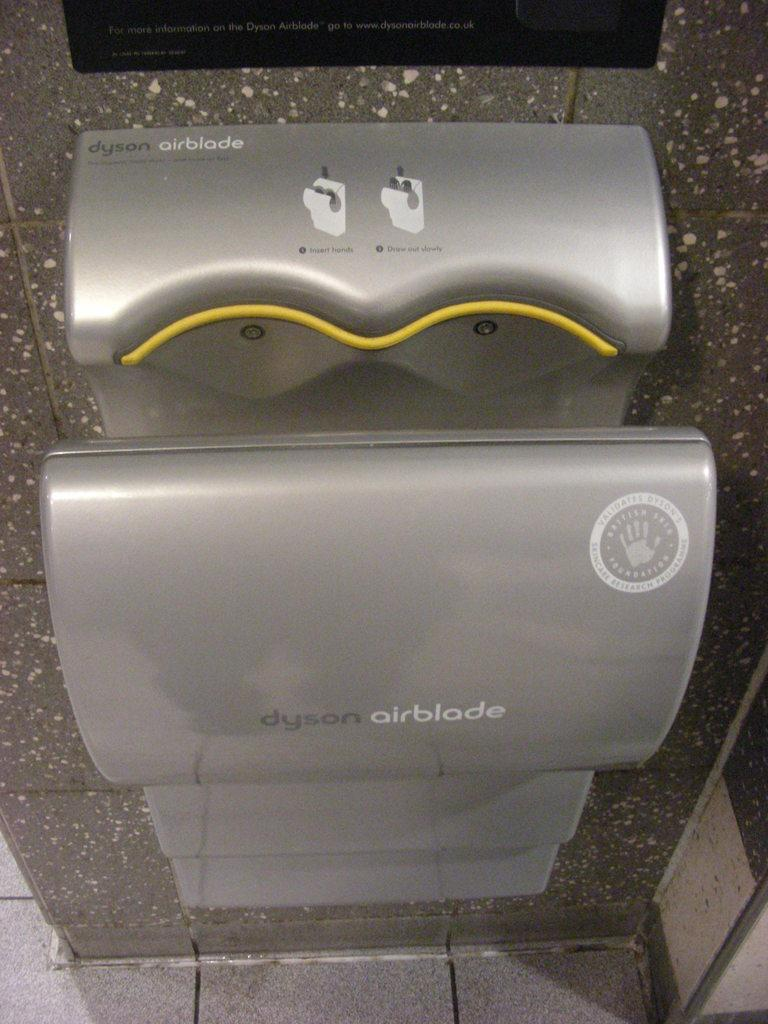<image>
Describe the image concisely. A dyson airblade touchless hand dryer hanging on a wall. 